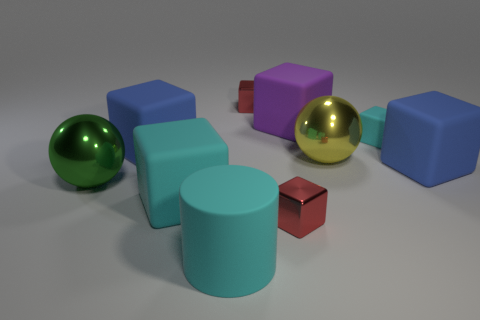Does the tiny metallic cube in front of the big green sphere have the same color as the metallic thing behind the purple rubber thing?
Offer a very short reply. Yes. There is a cube that is both on the left side of the big purple matte object and behind the small cyan cube; what is its color?
Offer a very short reply. Red. Is the material of the big yellow object the same as the small cyan object?
Offer a very short reply. No. What number of tiny things are either metallic spheres or brown cubes?
Your answer should be very brief. 0. The cylinder that is the same material as the small cyan cube is what color?
Provide a short and direct response. Cyan. What color is the matte block that is on the right side of the small cyan rubber thing?
Keep it short and to the point. Blue. How many big cubes are the same color as the large cylinder?
Offer a terse response. 1. Is the number of shiny things that are in front of the large cyan matte cube less than the number of cyan things in front of the large yellow metal sphere?
Make the answer very short. Yes. What number of small red things are in front of the small matte cube?
Offer a terse response. 1. Is there a large purple object that has the same material as the big green object?
Provide a succinct answer. No. 